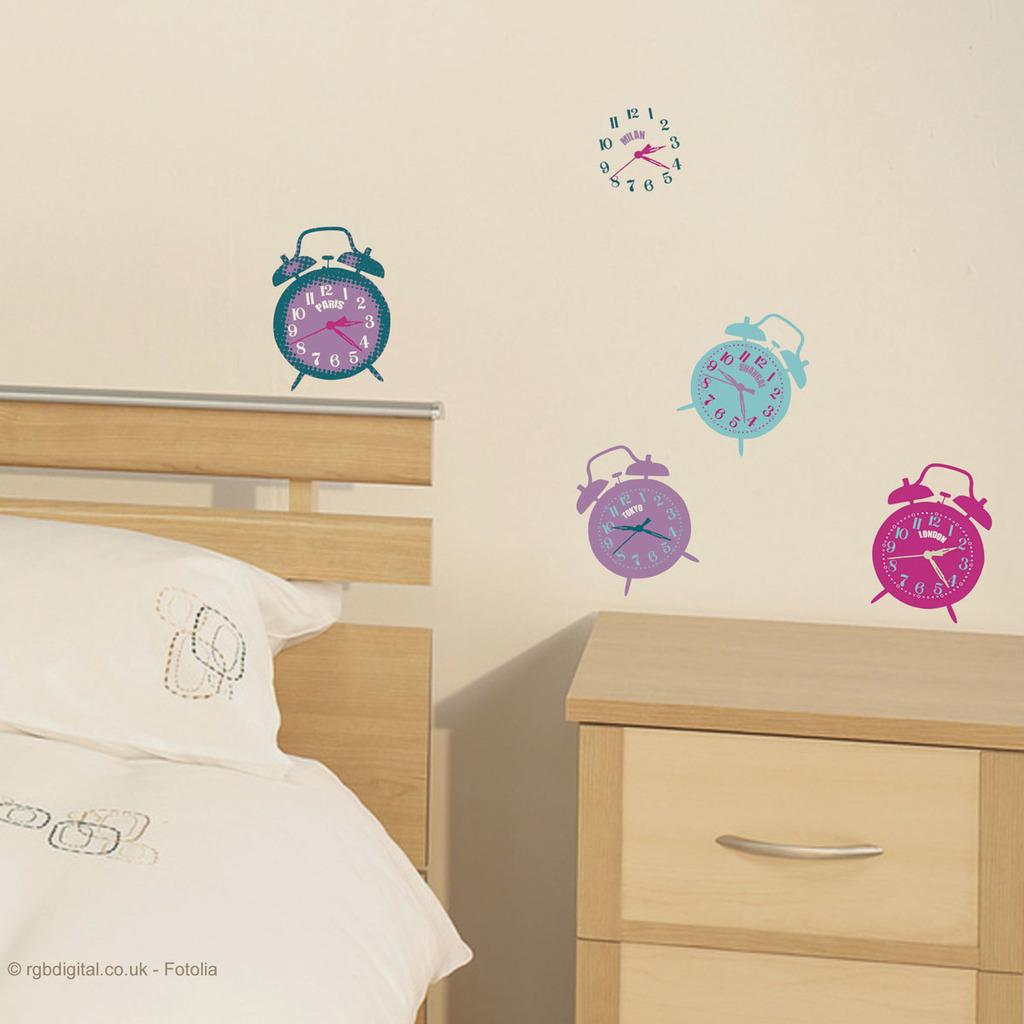What is placed on the bed in the image? There is a pillow on the bed in the image. What object can be seen in the image besides the pillow? There is a stand in the image. What decorative elements are present on the wall in the background of the image? There are stickers on the wall in the background of the image. What can be found at the bottom of the image? There is some text visible at the bottom of the image. What type of songs can be heard coming from the hole in the image? There is no hole present in the image, and therefore no songs can be heard. 